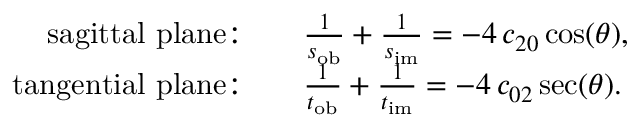Convert formula to latex. <formula><loc_0><loc_0><loc_500><loc_500>\begin{array} { r l } { s a g i t t a l p l a n e { \colon } \quad } & { \frac { 1 } { s _ { o b } } + \frac { 1 } { s _ { i m } } = - 4 \, c _ { 2 0 } \cos ( \theta ) , } \\ { t a n g e n t i a l p l a n e { \colon } \quad } & { \frac { 1 } { t _ { o b } } + \frac { 1 } { t _ { i m } } = - 4 \, c _ { 0 2 } \sec ( \theta ) . } \end{array}</formula> 